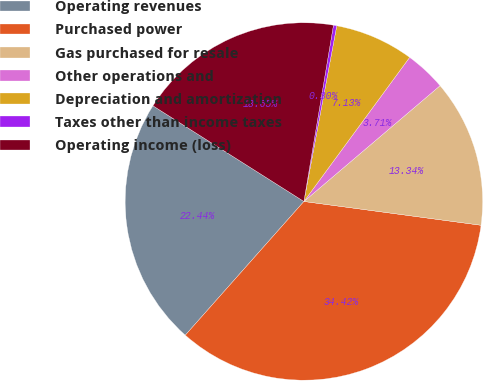<chart> <loc_0><loc_0><loc_500><loc_500><pie_chart><fcel>Operating revenues<fcel>Purchased power<fcel>Gas purchased for resale<fcel>Other operations and<fcel>Depreciation and amortization<fcel>Taxes other than income taxes<fcel>Operating income (loss)<nl><fcel>22.44%<fcel>34.42%<fcel>13.34%<fcel>3.71%<fcel>7.13%<fcel>0.3%<fcel>18.65%<nl></chart> 